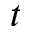Convert formula to latex. <formula><loc_0><loc_0><loc_500><loc_500>t</formula> 